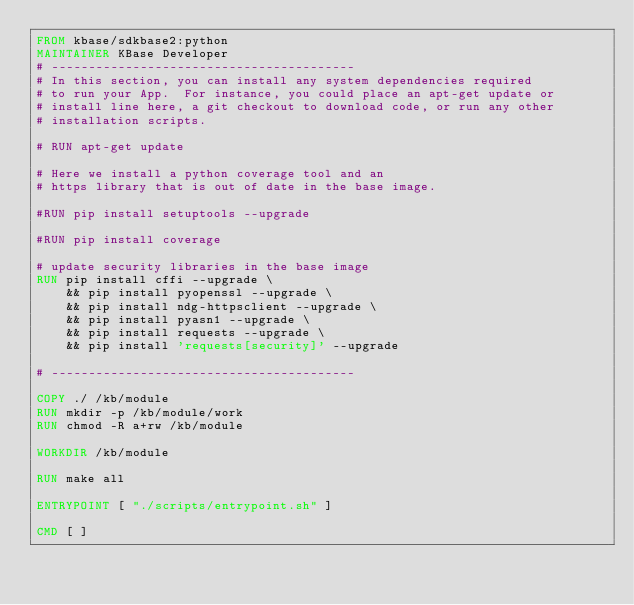Convert code to text. <code><loc_0><loc_0><loc_500><loc_500><_Dockerfile_>FROM kbase/sdkbase2:python
MAINTAINER KBase Developer
# -----------------------------------------
# In this section, you can install any system dependencies required
# to run your App.  For instance, you could place an apt-get update or
# install line here, a git checkout to download code, or run any other
# installation scripts.

# RUN apt-get update

# Here we install a python coverage tool and an
# https library that is out of date in the base image.

#RUN pip install setuptools --upgrade

#RUN pip install coverage

# update security libraries in the base image
RUN pip install cffi --upgrade \
    && pip install pyopenssl --upgrade \
    && pip install ndg-httpsclient --upgrade \
    && pip install pyasn1 --upgrade \
    && pip install requests --upgrade \
    && pip install 'requests[security]' --upgrade

# -----------------------------------------

COPY ./ /kb/module
RUN mkdir -p /kb/module/work
RUN chmod -R a+rw /kb/module

WORKDIR /kb/module

RUN make all

ENTRYPOINT [ "./scripts/entrypoint.sh" ]

CMD [ ]
</code> 